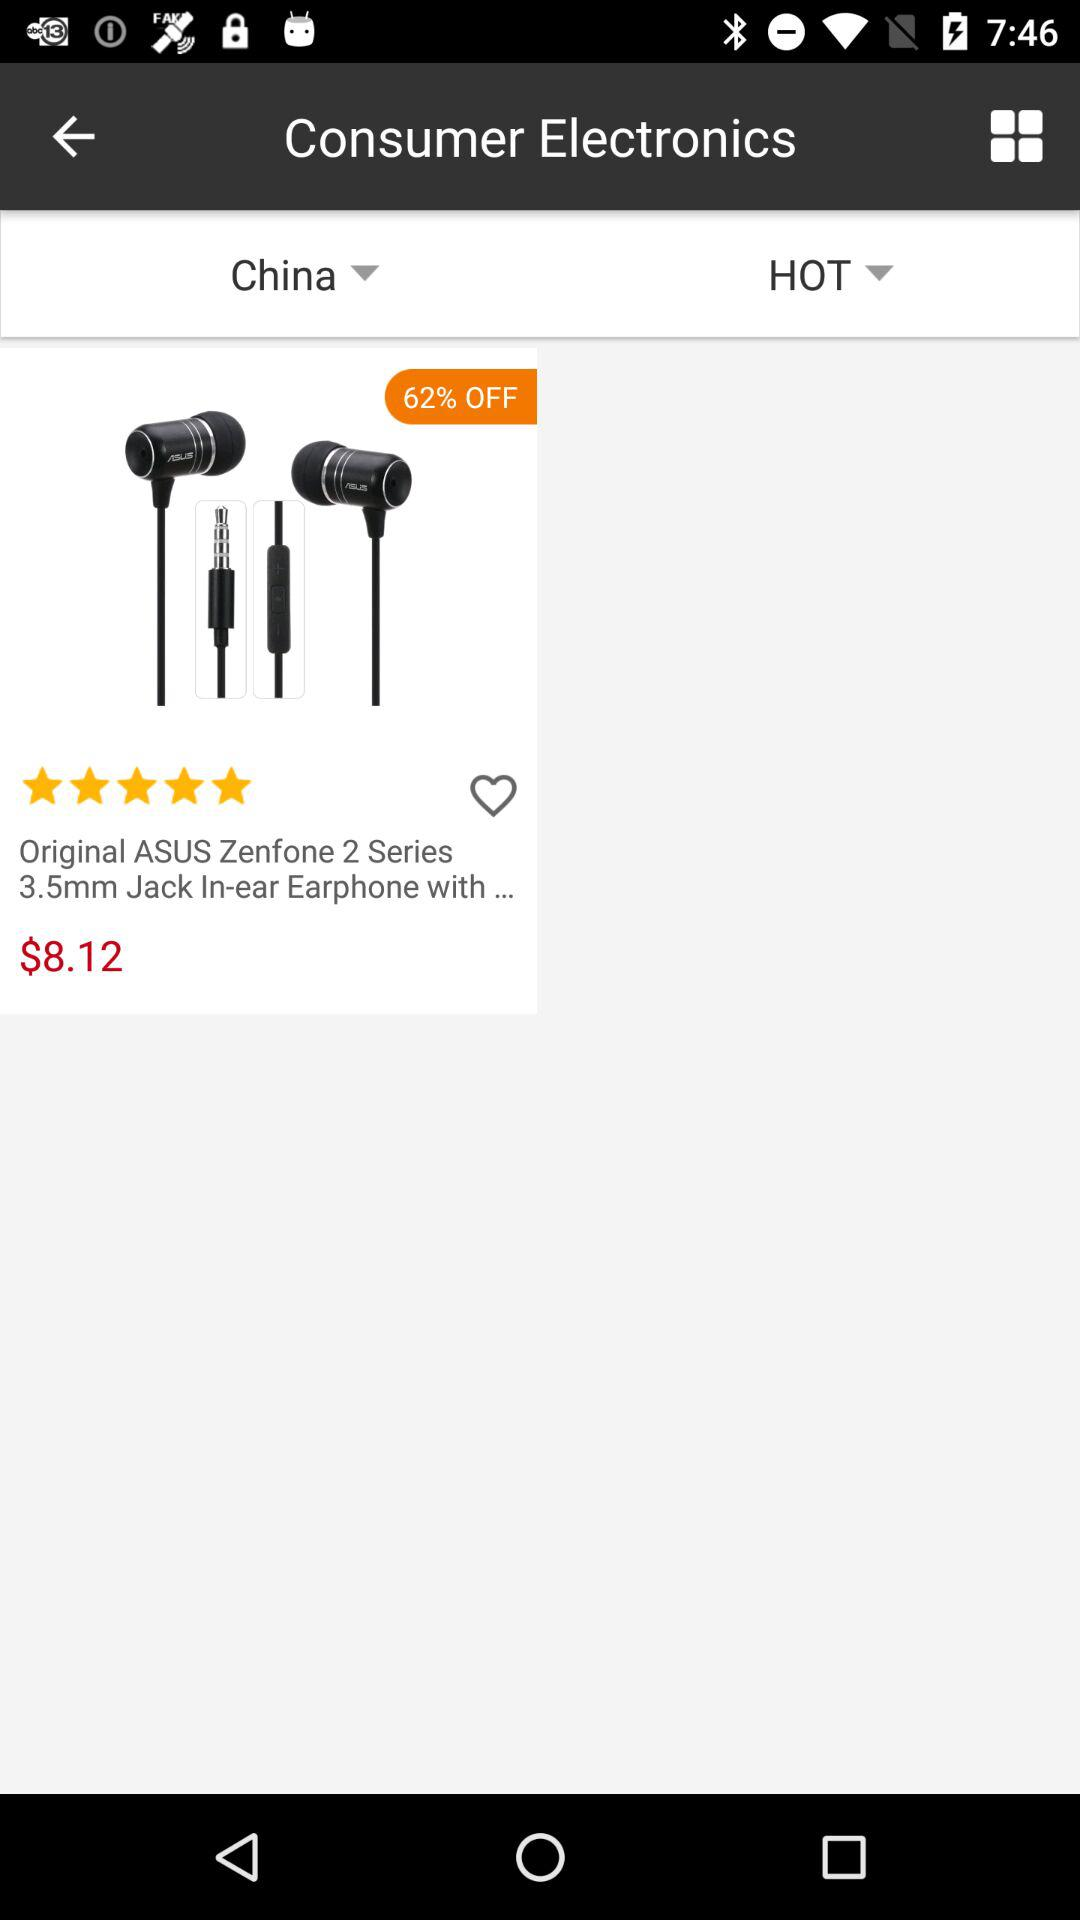What is the rating of the earphones? The rating of the earphones is 5 stars. 